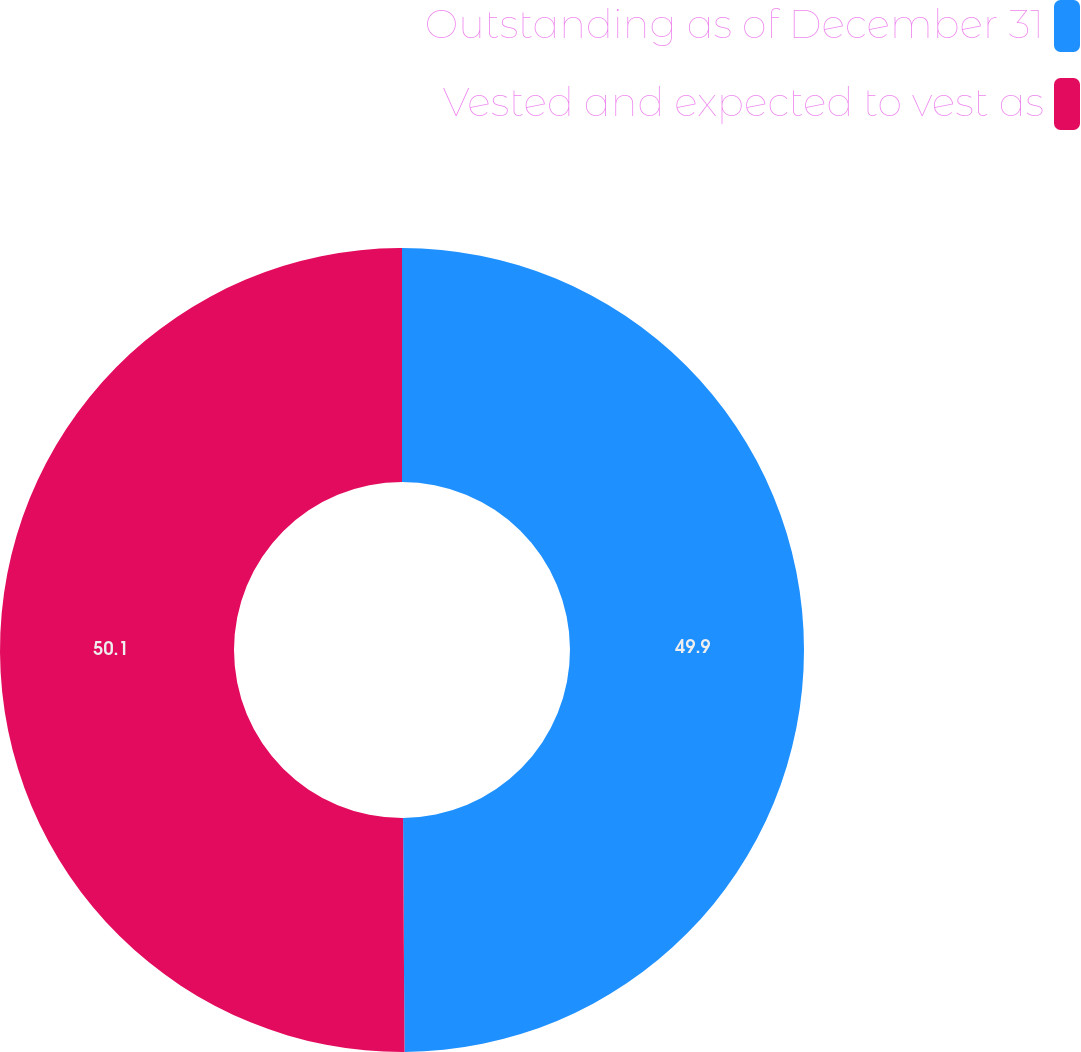Convert chart. <chart><loc_0><loc_0><loc_500><loc_500><pie_chart><fcel>Outstanding as of December 31<fcel>Vested and expected to vest as<nl><fcel>49.9%<fcel>50.1%<nl></chart> 